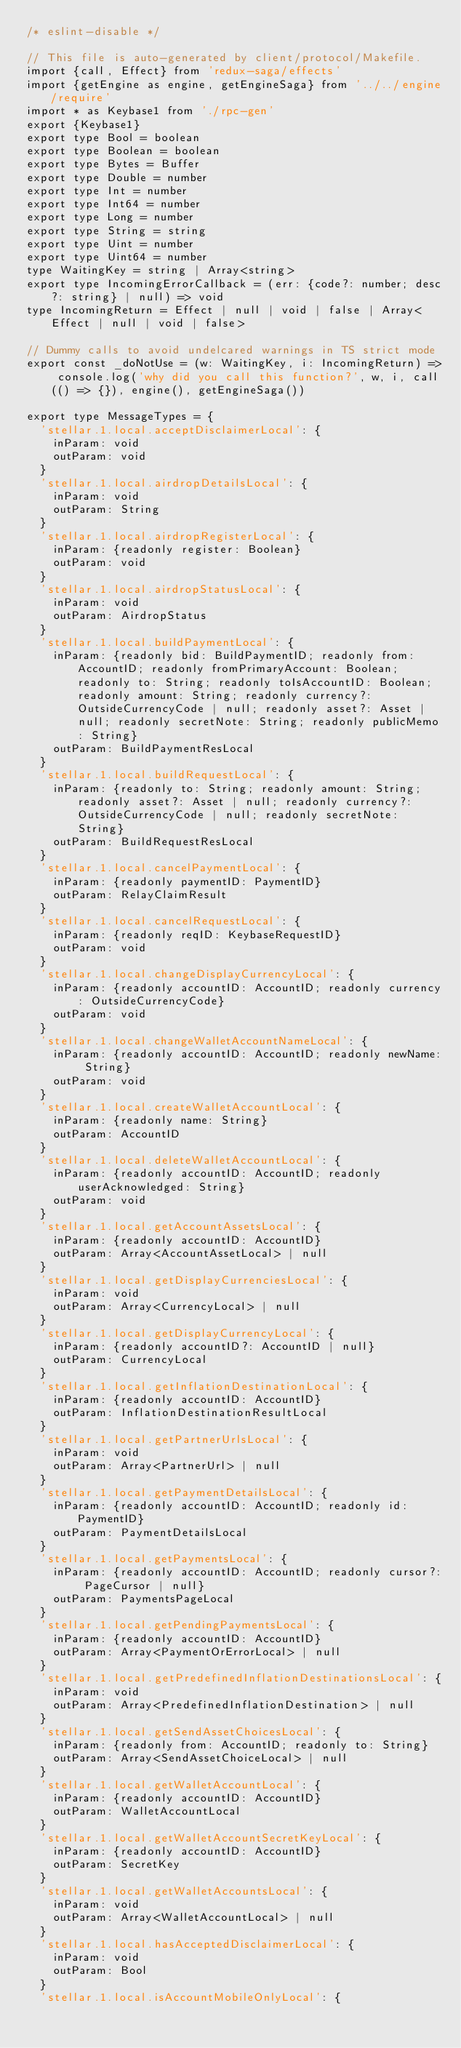Convert code to text. <code><loc_0><loc_0><loc_500><loc_500><_TypeScript_>/* eslint-disable */

// This file is auto-generated by client/protocol/Makefile.
import {call, Effect} from 'redux-saga/effects'
import {getEngine as engine, getEngineSaga} from '../../engine/require'
import * as Keybase1 from './rpc-gen'
export {Keybase1}
export type Bool = boolean
export type Boolean = boolean
export type Bytes = Buffer
export type Double = number
export type Int = number
export type Int64 = number
export type Long = number
export type String = string
export type Uint = number
export type Uint64 = number
type WaitingKey = string | Array<string>
export type IncomingErrorCallback = (err: {code?: number; desc?: string} | null) => void
type IncomingReturn = Effect | null | void | false | Array<Effect | null | void | false>

// Dummy calls to avoid undelcared warnings in TS strict mode
export const _doNotUse = (w: WaitingKey, i: IncomingReturn) => console.log('why did you call this function?', w, i, call(() => {}), engine(), getEngineSaga())

export type MessageTypes = {
  'stellar.1.local.acceptDisclaimerLocal': {
    inParam: void
    outParam: void
  }
  'stellar.1.local.airdropDetailsLocal': {
    inParam: void
    outParam: String
  }
  'stellar.1.local.airdropRegisterLocal': {
    inParam: {readonly register: Boolean}
    outParam: void
  }
  'stellar.1.local.airdropStatusLocal': {
    inParam: void
    outParam: AirdropStatus
  }
  'stellar.1.local.buildPaymentLocal': {
    inParam: {readonly bid: BuildPaymentID; readonly from: AccountID; readonly fromPrimaryAccount: Boolean; readonly to: String; readonly toIsAccountID: Boolean; readonly amount: String; readonly currency?: OutsideCurrencyCode | null; readonly asset?: Asset | null; readonly secretNote: String; readonly publicMemo: String}
    outParam: BuildPaymentResLocal
  }
  'stellar.1.local.buildRequestLocal': {
    inParam: {readonly to: String; readonly amount: String; readonly asset?: Asset | null; readonly currency?: OutsideCurrencyCode | null; readonly secretNote: String}
    outParam: BuildRequestResLocal
  }
  'stellar.1.local.cancelPaymentLocal': {
    inParam: {readonly paymentID: PaymentID}
    outParam: RelayClaimResult
  }
  'stellar.1.local.cancelRequestLocal': {
    inParam: {readonly reqID: KeybaseRequestID}
    outParam: void
  }
  'stellar.1.local.changeDisplayCurrencyLocal': {
    inParam: {readonly accountID: AccountID; readonly currency: OutsideCurrencyCode}
    outParam: void
  }
  'stellar.1.local.changeWalletAccountNameLocal': {
    inParam: {readonly accountID: AccountID; readonly newName: String}
    outParam: void
  }
  'stellar.1.local.createWalletAccountLocal': {
    inParam: {readonly name: String}
    outParam: AccountID
  }
  'stellar.1.local.deleteWalletAccountLocal': {
    inParam: {readonly accountID: AccountID; readonly userAcknowledged: String}
    outParam: void
  }
  'stellar.1.local.getAccountAssetsLocal': {
    inParam: {readonly accountID: AccountID}
    outParam: Array<AccountAssetLocal> | null
  }
  'stellar.1.local.getDisplayCurrenciesLocal': {
    inParam: void
    outParam: Array<CurrencyLocal> | null
  }
  'stellar.1.local.getDisplayCurrencyLocal': {
    inParam: {readonly accountID?: AccountID | null}
    outParam: CurrencyLocal
  }
  'stellar.1.local.getInflationDestinationLocal': {
    inParam: {readonly accountID: AccountID}
    outParam: InflationDestinationResultLocal
  }
  'stellar.1.local.getPartnerUrlsLocal': {
    inParam: void
    outParam: Array<PartnerUrl> | null
  }
  'stellar.1.local.getPaymentDetailsLocal': {
    inParam: {readonly accountID: AccountID; readonly id: PaymentID}
    outParam: PaymentDetailsLocal
  }
  'stellar.1.local.getPaymentsLocal': {
    inParam: {readonly accountID: AccountID; readonly cursor?: PageCursor | null}
    outParam: PaymentsPageLocal
  }
  'stellar.1.local.getPendingPaymentsLocal': {
    inParam: {readonly accountID: AccountID}
    outParam: Array<PaymentOrErrorLocal> | null
  }
  'stellar.1.local.getPredefinedInflationDestinationsLocal': {
    inParam: void
    outParam: Array<PredefinedInflationDestination> | null
  }
  'stellar.1.local.getSendAssetChoicesLocal': {
    inParam: {readonly from: AccountID; readonly to: String}
    outParam: Array<SendAssetChoiceLocal> | null
  }
  'stellar.1.local.getWalletAccountLocal': {
    inParam: {readonly accountID: AccountID}
    outParam: WalletAccountLocal
  }
  'stellar.1.local.getWalletAccountSecretKeyLocal': {
    inParam: {readonly accountID: AccountID}
    outParam: SecretKey
  }
  'stellar.1.local.getWalletAccountsLocal': {
    inParam: void
    outParam: Array<WalletAccountLocal> | null
  }
  'stellar.1.local.hasAcceptedDisclaimerLocal': {
    inParam: void
    outParam: Bool
  }
  'stellar.1.local.isAccountMobileOnlyLocal': {</code> 